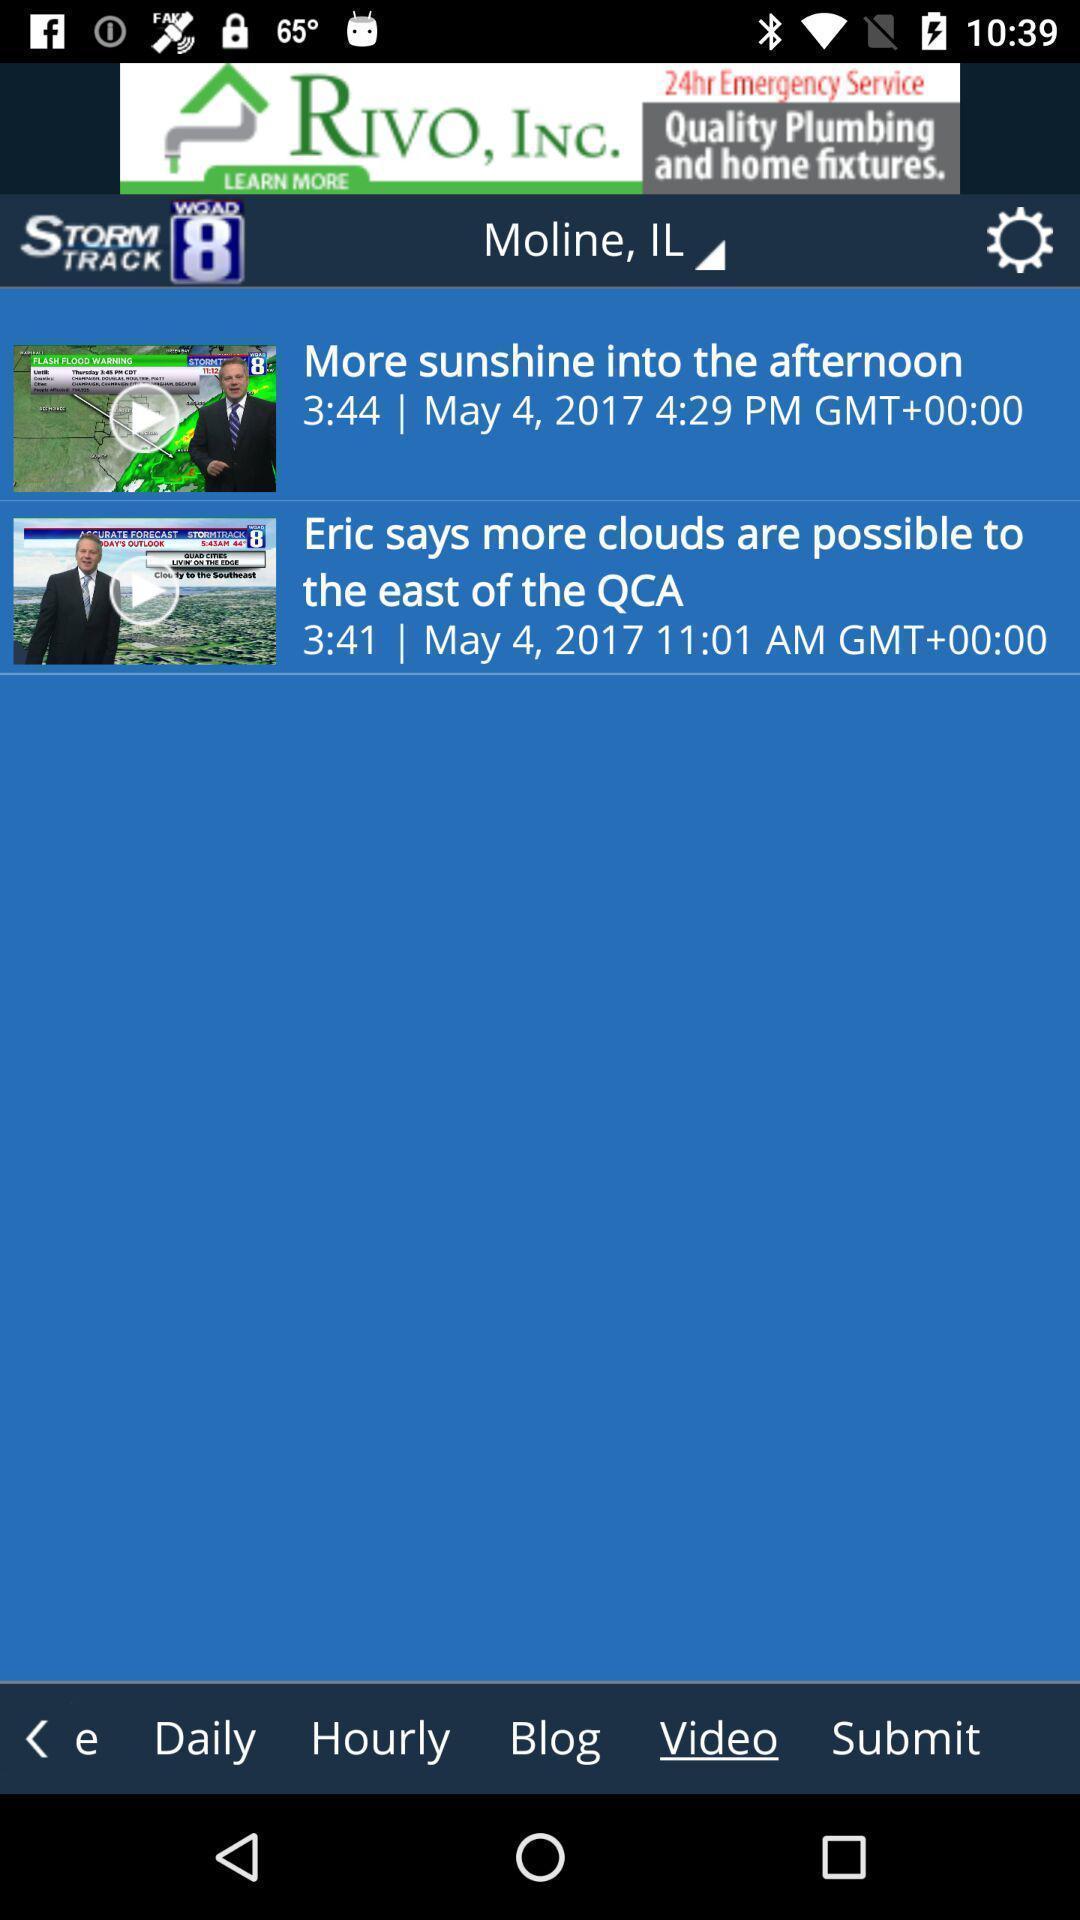What can you discern from this picture? Various articles displayed of a weather forecast app. 